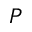<formula> <loc_0><loc_0><loc_500><loc_500>P</formula> 